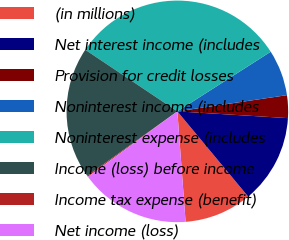Convert chart. <chart><loc_0><loc_0><loc_500><loc_500><pie_chart><fcel>(in millions)<fcel>Net interest income (includes<fcel>Provision for credit losses<fcel>Noninterest income (includes<fcel>Noninterest expense (includes<fcel>Income (loss) before income<fcel>Income tax expense (benefit)<fcel>Net income (loss)<nl><fcel>9.85%<fcel>12.99%<fcel>3.31%<fcel>6.71%<fcel>31.57%<fcel>19.27%<fcel>0.17%<fcel>16.13%<nl></chart> 